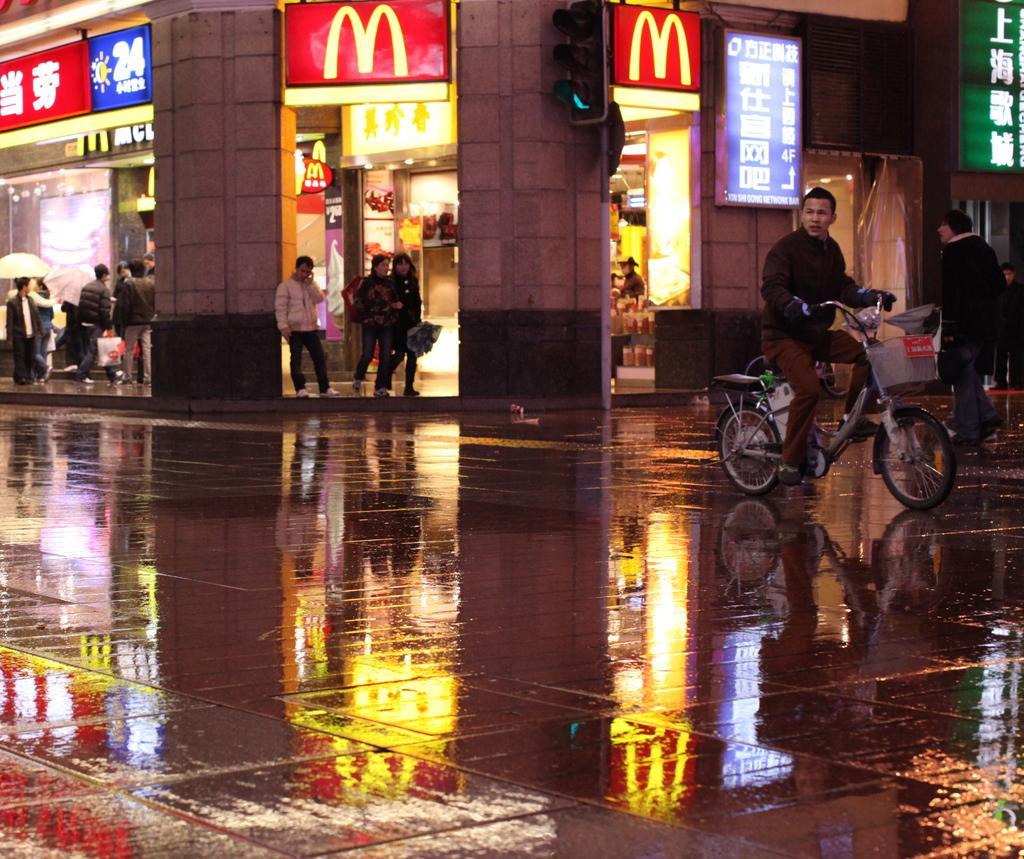Describe this image in one or two sentences. This picture is kept outside the city. On the right of the picture, we see man in black jacket is riding bicycle. Beside him, an old man in black shirt is walking. Behind this man, we see many stalls and people are standing before the stall. Beside them, we see two pillars. On one of the pillar, we see traffic light. Beside this pillar, we see hoarding boards. 